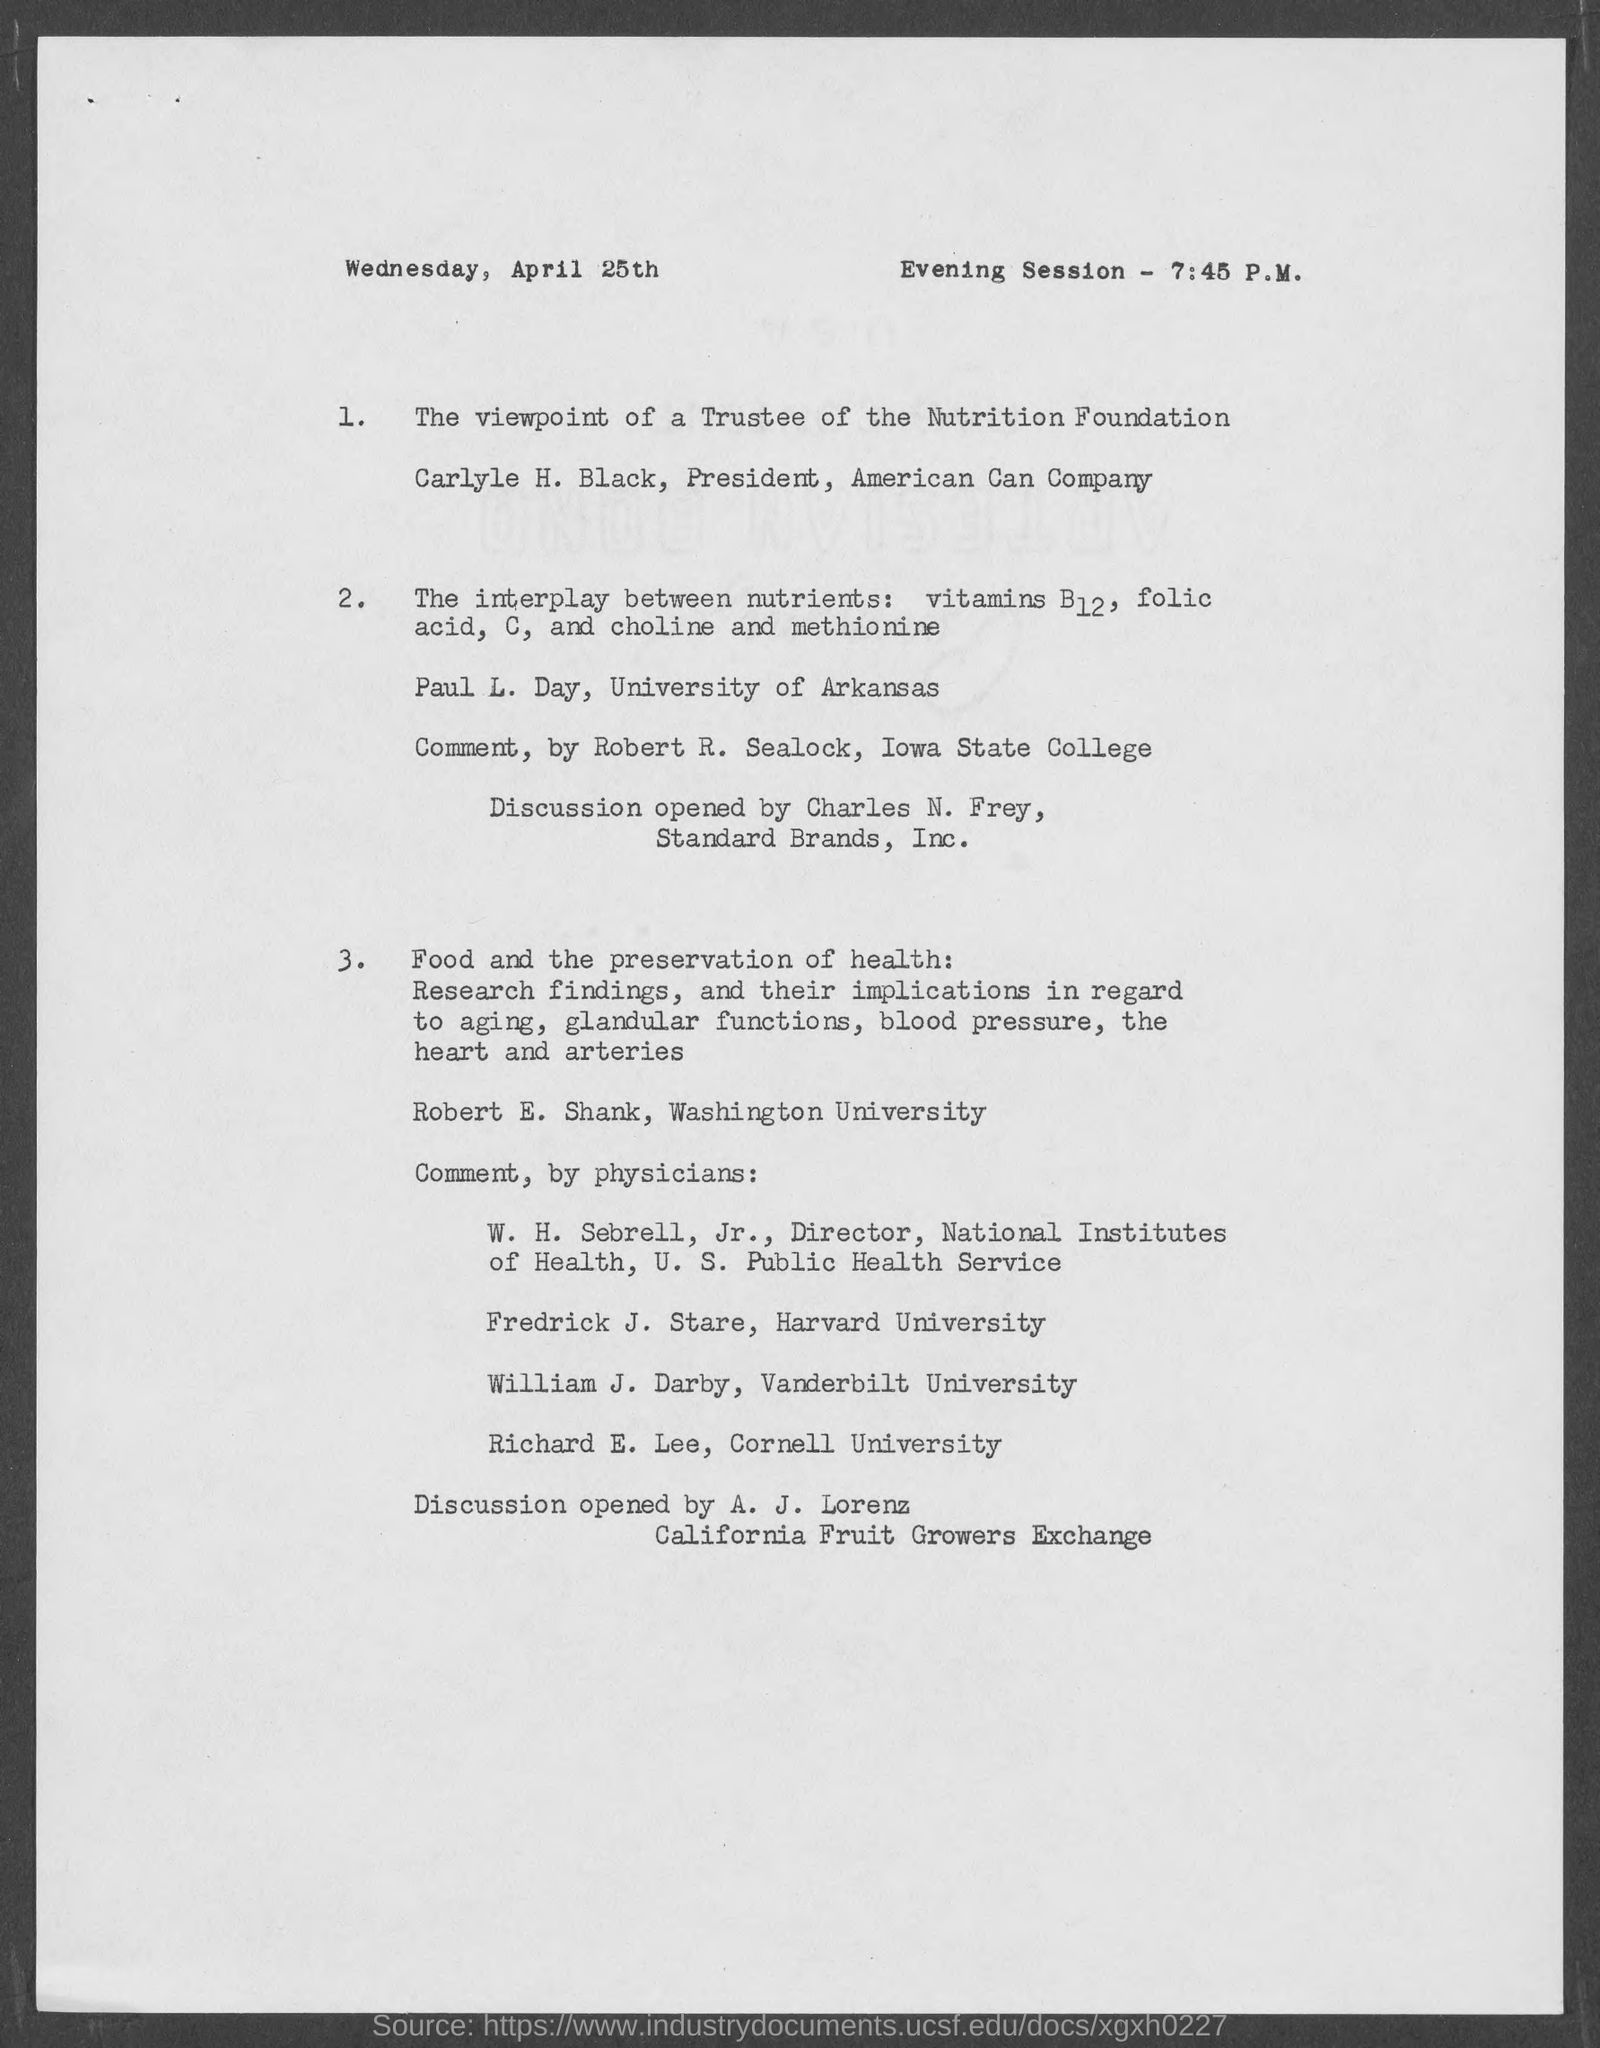When is the document dated?
Give a very brief answer. Wednesday, April 25th. At what time is the Evening Session?
Offer a terse response. 7:45 P.M. Who is the president of American Can Company?
Ensure brevity in your answer.  Carlyle H. Black. Who will open discussion?
Make the answer very short. A. J. Lorenz. Which University is Richard E. Lee part of?
Ensure brevity in your answer.  Cornell University. 